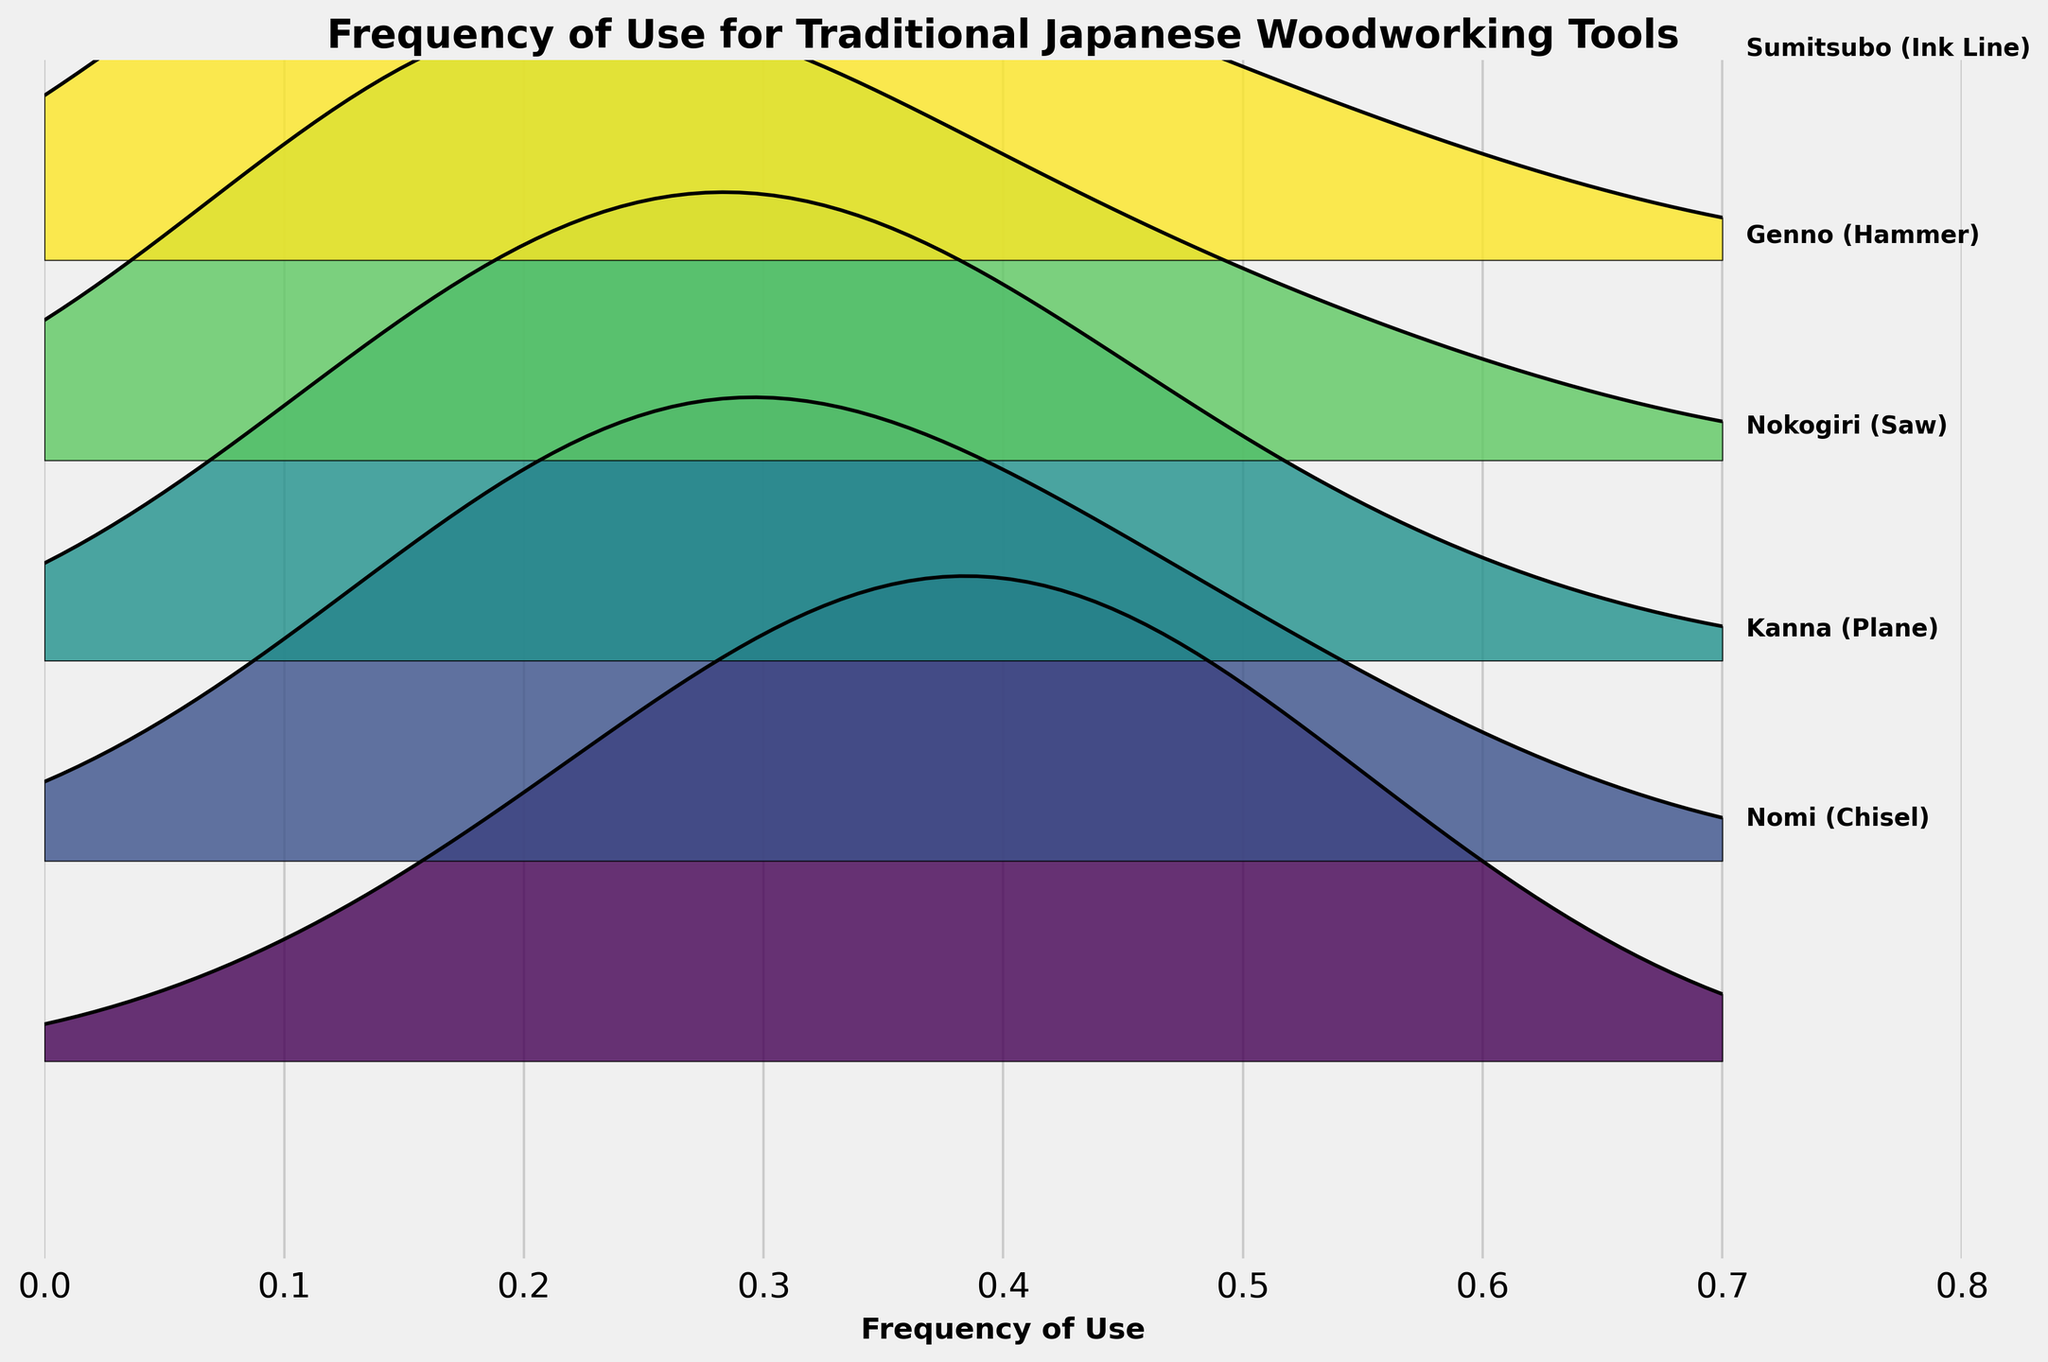What is the title of the figure? The title is usually located at the top of the plot and provides a summary of what the figure represents. Here, the title clearly states "Frequency of Use for Traditional Japanese Woodworking Tools."
Answer: Frequency of Use for Traditional Japanese Woodworking Tools What does the x-axis represent? The x-axis label is typically found below the horizontal axis and indicates what the data on this axis represents. In this figure, it is labeled as "Frequency of Use."
Answer: Frequency of Use How many different woodworking tools are represented in the figure? Each ridgeline in the figure corresponds to a different woodworking tool, and the presence of different text labels for each ridgeline shows the number of tools. There are five different labels.
Answer: Five Which tool has the highest usage at a frequency of 0.4? To determine this, we need to look at the height of the ridgeline plot at the x-axis value of 0.4 for each tool and compare them. The Nomi (Chisel) ridgeline at frequency 0.4 is the highest.
Answer: Nomi (Chisel) Among the tools, which has the least frequency of use at a frequency of 0.6? This can be determined by comparing the heights of all ridgeline plots at frequency 0.6. All tools have low usage at this frequency, but tools with the smallest ridgeline height at this point are Kanna (Plane), Nokogiri (Saw), Genno (Hammer), and Sumitsubo (Ink Line).
Answer: Kanna, Nokogiri, Genno, Sumitsubo Which tool shows the most consistent usage across all frequencies? Consistent usage is indicated by a relatively even spread of the ridgeline plot heights across different frequencies. The Nomi (Chisel) seems to have a more consistent spread of usage heights across frequencies compared to other tools.
Answer: Nomi (Chisel) Between Kanna (Plane) and Genno (Hammer), which tool has higher usage at a frequency of 0.2? At frequency 0.2, the heights of the ridgeline plots for each tool show the usage. Kanna (Plane) has a height of 25 while Genno (Hammer) has a height of 35 at this frequency.
Answer: Genno (Hammer) By comparing all tools, which tool seems to have the highest peak usage? The peak usage for each tool is indicated by the highest point of its ridgeline plot. Genno (Hammer) has a significant peak at frequency 0.2, reaching higher than peaks of other tools.
Answer: Genno (Hammer) Is there any tool that shows a single distinct frequency with the highest usage, without other frequencies being similarly high? Yes, Genno (Hammer) shows a pronounced peak at frequency 0.2, while other frequencies have much lower usage values, indicating a single distinct high usage frequency.
Answer: Genno (Hammer) Which tool has the least variation in usage across the frequencies? Least variation can be observed when ridgeline heights are similar across frequencies. The Nomi (Chisel) shows this characteristic as it has relatively balanced usage.
Answer: Nomi (Chisel) 